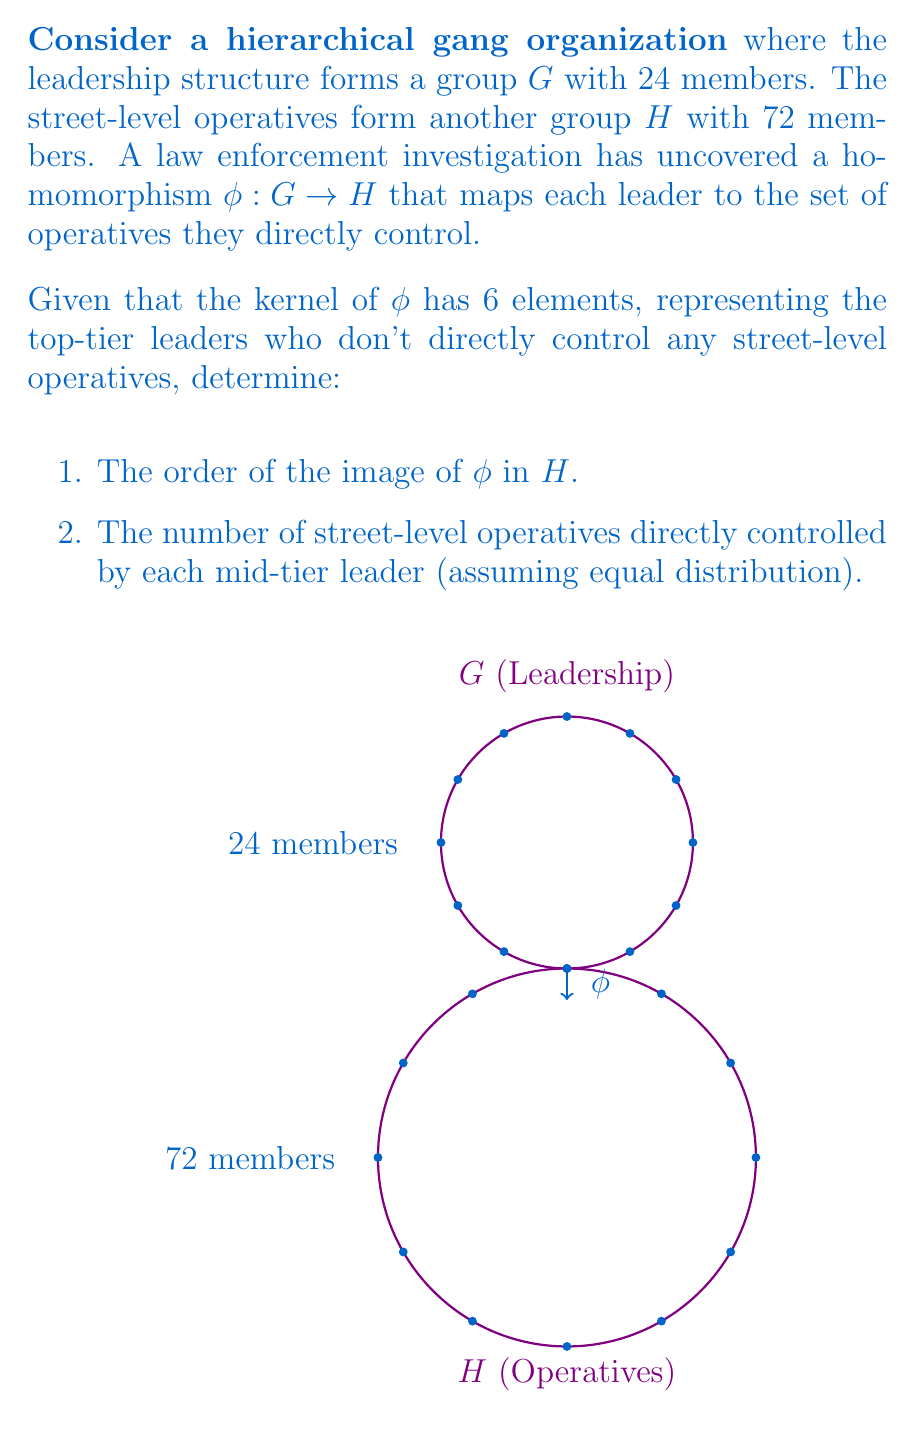Solve this math problem. Let's approach this step-by-step:

1) First, we'll use the First Isomorphism Theorem, which states that for a group homomorphism $\phi : G \rightarrow H$, we have:

   $$G / \text{ker}(\phi) \cong \text{im}(\phi)$$

2) We're given that $|\text{ker}(\phi)| = 6$ and $|G| = 24$.

3) Using Lagrange's theorem, we know that:

   $$|G| = |\text{ker}(\phi)| \cdot |\text{im}(\phi)|$$

4) Substituting the known values:

   $$24 = 6 \cdot |\text{im}(\phi)|$$

5) Solving for $|\text{im}(\phi)|$:

   $$|\text{im}(\phi)| = 24 / 6 = 4$$

   This answers the first part of the question.

6) For the second part, we need to consider that the image of $\phi$ represents the mid-tier leaders who directly control street-level operatives.

7) We know there are 72 street-level operatives in total, and they are controlled by 4 mid-tier leaders (the elements in the image of $\phi$).

8) Assuming equal distribution, each mid-tier leader controls:

   $$72 / 4 = 18$$ street-level operatives.

This analysis provides insights into the structure of the gang organization, showing how group theory can be applied to understand hierarchical criminal structures.
Answer: 1) $|\text{im}(\phi)| = 4$
2) 18 operatives per mid-tier leader 